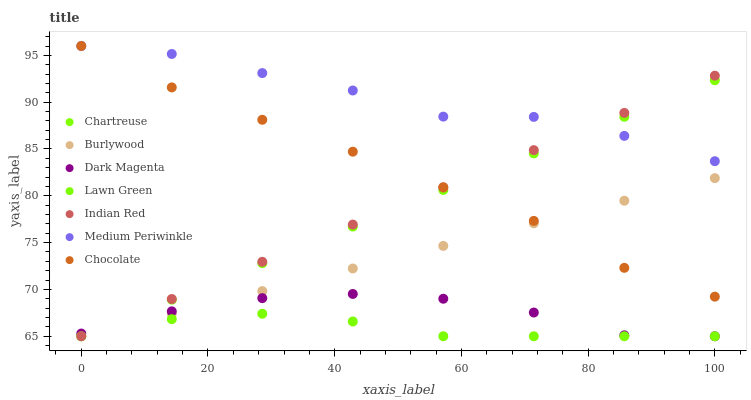Does Lawn Green have the minimum area under the curve?
Answer yes or no. Yes. Does Medium Periwinkle have the maximum area under the curve?
Answer yes or no. Yes. Does Dark Magenta have the minimum area under the curve?
Answer yes or no. No. Does Dark Magenta have the maximum area under the curve?
Answer yes or no. No. Is Chartreuse the smoothest?
Answer yes or no. Yes. Is Medium Periwinkle the roughest?
Answer yes or no. Yes. Is Dark Magenta the smoothest?
Answer yes or no. No. Is Dark Magenta the roughest?
Answer yes or no. No. Does Lawn Green have the lowest value?
Answer yes or no. Yes. Does Medium Periwinkle have the lowest value?
Answer yes or no. No. Does Chocolate have the highest value?
Answer yes or no. Yes. Does Dark Magenta have the highest value?
Answer yes or no. No. Is Lawn Green less than Chocolate?
Answer yes or no. Yes. Is Medium Periwinkle greater than Burlywood?
Answer yes or no. Yes. Does Chocolate intersect Chartreuse?
Answer yes or no. Yes. Is Chocolate less than Chartreuse?
Answer yes or no. No. Is Chocolate greater than Chartreuse?
Answer yes or no. No. Does Lawn Green intersect Chocolate?
Answer yes or no. No. 